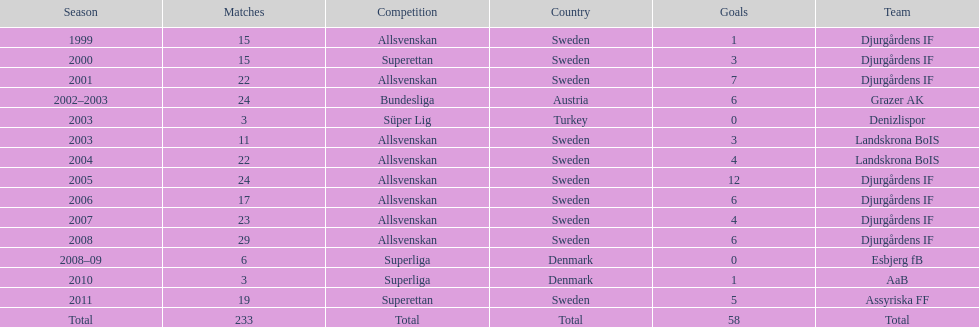In which country is team djurgårdens if not based? Sweden. 